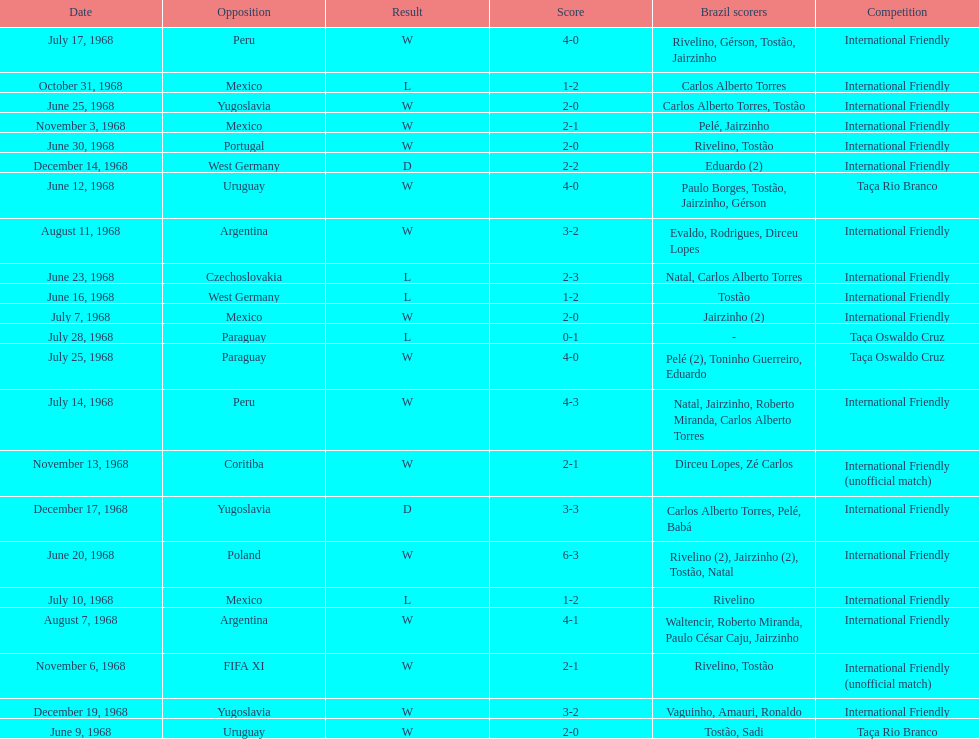How many instances did brazil score during the event on november 6th? 2. 